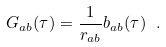Convert formula to latex. <formula><loc_0><loc_0><loc_500><loc_500>G _ { a b } ( \tau ) = \frac { 1 } { r _ { a b } } b _ { a b } ( \tau ) \ .</formula> 